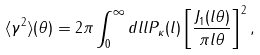<formula> <loc_0><loc_0><loc_500><loc_500>\langle \gamma ^ { 2 } \rangle ( \theta ) = 2 \pi \int _ { 0 } ^ { \infty } d l l P _ { \kappa } ( l ) \left [ \frac { J _ { 1 } ( l \theta ) } { \pi l \theta } \right ] ^ { 2 } ,</formula> 